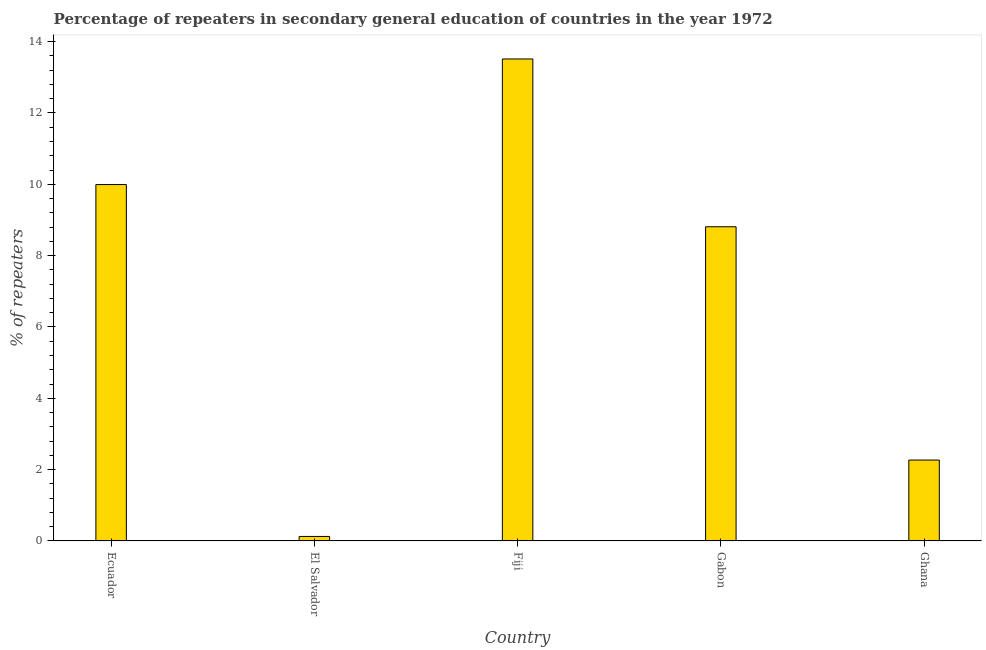Does the graph contain any zero values?
Ensure brevity in your answer.  No. What is the title of the graph?
Your answer should be compact. Percentage of repeaters in secondary general education of countries in the year 1972. What is the label or title of the X-axis?
Your answer should be compact. Country. What is the label or title of the Y-axis?
Ensure brevity in your answer.  % of repeaters. What is the percentage of repeaters in Fiji?
Offer a terse response. 13.51. Across all countries, what is the maximum percentage of repeaters?
Give a very brief answer. 13.51. Across all countries, what is the minimum percentage of repeaters?
Your response must be concise. 0.13. In which country was the percentage of repeaters maximum?
Your answer should be compact. Fiji. In which country was the percentage of repeaters minimum?
Keep it short and to the point. El Salvador. What is the sum of the percentage of repeaters?
Your response must be concise. 34.71. What is the difference between the percentage of repeaters in Fiji and Ghana?
Offer a very short reply. 11.24. What is the average percentage of repeaters per country?
Ensure brevity in your answer.  6.94. What is the median percentage of repeaters?
Provide a succinct answer. 8.81. What is the ratio of the percentage of repeaters in Ecuador to that in Fiji?
Offer a terse response. 0.74. Is the difference between the percentage of repeaters in Fiji and Gabon greater than the difference between any two countries?
Offer a terse response. No. What is the difference between the highest and the second highest percentage of repeaters?
Provide a succinct answer. 3.52. Is the sum of the percentage of repeaters in Gabon and Ghana greater than the maximum percentage of repeaters across all countries?
Your response must be concise. No. What is the difference between the highest and the lowest percentage of repeaters?
Provide a short and direct response. 13.39. How many countries are there in the graph?
Ensure brevity in your answer.  5. Are the values on the major ticks of Y-axis written in scientific E-notation?
Your response must be concise. No. What is the % of repeaters in Ecuador?
Your answer should be compact. 9.99. What is the % of repeaters in El Salvador?
Your response must be concise. 0.13. What is the % of repeaters in Fiji?
Offer a terse response. 13.51. What is the % of repeaters in Gabon?
Your answer should be compact. 8.81. What is the % of repeaters of Ghana?
Provide a succinct answer. 2.27. What is the difference between the % of repeaters in Ecuador and El Salvador?
Offer a terse response. 9.87. What is the difference between the % of repeaters in Ecuador and Fiji?
Offer a very short reply. -3.52. What is the difference between the % of repeaters in Ecuador and Gabon?
Your answer should be very brief. 1.18. What is the difference between the % of repeaters in Ecuador and Ghana?
Make the answer very short. 7.72. What is the difference between the % of repeaters in El Salvador and Fiji?
Offer a very short reply. -13.39. What is the difference between the % of repeaters in El Salvador and Gabon?
Offer a very short reply. -8.68. What is the difference between the % of repeaters in El Salvador and Ghana?
Your answer should be very brief. -2.14. What is the difference between the % of repeaters in Fiji and Gabon?
Your response must be concise. 4.7. What is the difference between the % of repeaters in Fiji and Ghana?
Keep it short and to the point. 11.25. What is the difference between the % of repeaters in Gabon and Ghana?
Ensure brevity in your answer.  6.54. What is the ratio of the % of repeaters in Ecuador to that in El Salvador?
Provide a succinct answer. 78.63. What is the ratio of the % of repeaters in Ecuador to that in Fiji?
Your answer should be compact. 0.74. What is the ratio of the % of repeaters in Ecuador to that in Gabon?
Give a very brief answer. 1.13. What is the ratio of the % of repeaters in Ecuador to that in Ghana?
Offer a terse response. 4.41. What is the ratio of the % of repeaters in El Salvador to that in Fiji?
Offer a terse response. 0.01. What is the ratio of the % of repeaters in El Salvador to that in Gabon?
Your answer should be compact. 0.01. What is the ratio of the % of repeaters in El Salvador to that in Ghana?
Keep it short and to the point. 0.06. What is the ratio of the % of repeaters in Fiji to that in Gabon?
Offer a terse response. 1.53. What is the ratio of the % of repeaters in Fiji to that in Ghana?
Your response must be concise. 5.96. What is the ratio of the % of repeaters in Gabon to that in Ghana?
Your answer should be compact. 3.88. 